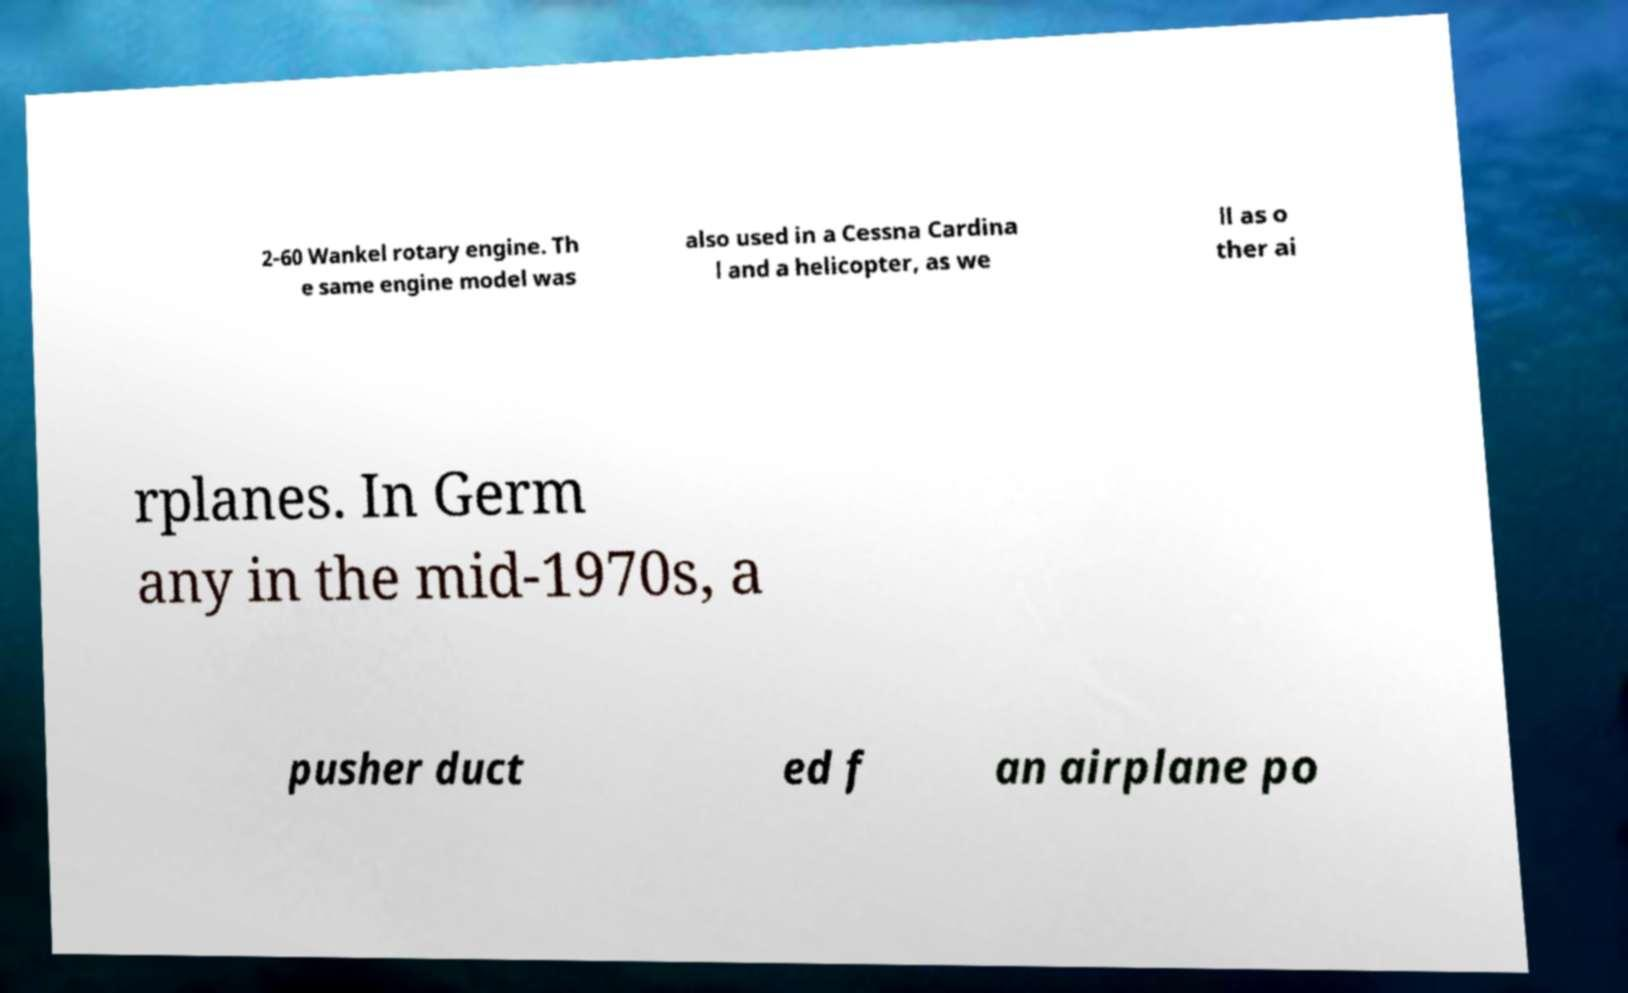Could you assist in decoding the text presented in this image and type it out clearly? 2-60 Wankel rotary engine. Th e same engine model was also used in a Cessna Cardina l and a helicopter, as we ll as o ther ai rplanes. In Germ any in the mid-1970s, a pusher duct ed f an airplane po 